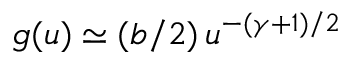Convert formula to latex. <formula><loc_0><loc_0><loc_500><loc_500>g ( u ) \simeq ( b / 2 ) \, u ^ { - ( \gamma + 1 ) / 2 }</formula> 